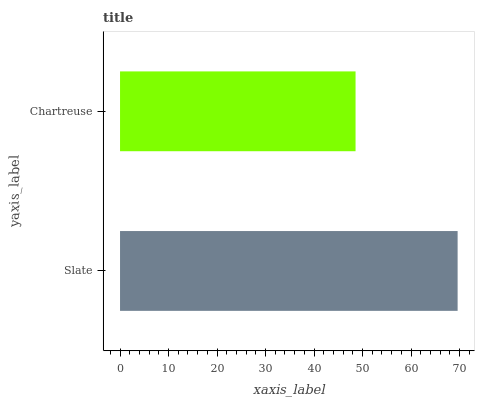Is Chartreuse the minimum?
Answer yes or no. Yes. Is Slate the maximum?
Answer yes or no. Yes. Is Chartreuse the maximum?
Answer yes or no. No. Is Slate greater than Chartreuse?
Answer yes or no. Yes. Is Chartreuse less than Slate?
Answer yes or no. Yes. Is Chartreuse greater than Slate?
Answer yes or no. No. Is Slate less than Chartreuse?
Answer yes or no. No. Is Slate the high median?
Answer yes or no. Yes. Is Chartreuse the low median?
Answer yes or no. Yes. Is Chartreuse the high median?
Answer yes or no. No. Is Slate the low median?
Answer yes or no. No. 